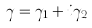<formula> <loc_0><loc_0><loc_500><loc_500>\gamma = \gamma _ { 1 } + i \gamma _ { 2 }</formula> 